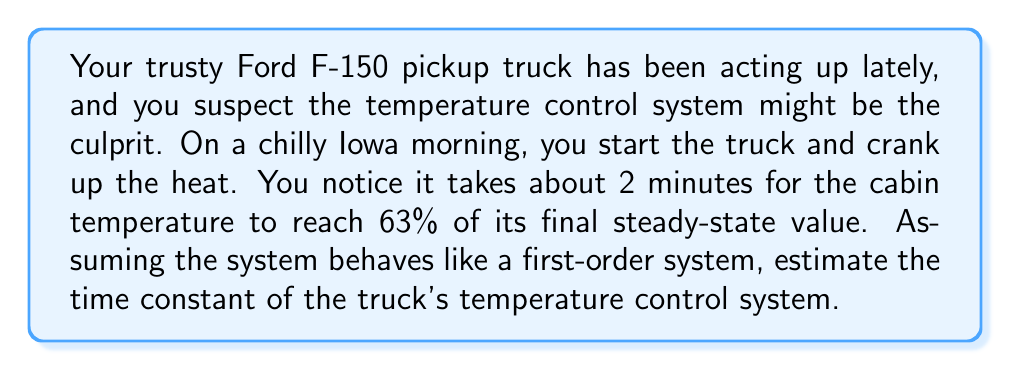Show me your answer to this math problem. To solve this problem, we'll use the properties of a first-order system and the given information. Here's a step-by-step explanation:

1) In a first-order system, the time constant ($\tau$) is defined as the time it takes for the system to reach 63.2% of its final steady-state value.

2) We're told that the cabin temperature reaches 63% of its final value in 2 minutes. This is very close to the definition of the time constant (63.2%).

3) Therefore, we can approximate the time constant as being equal to the time given:

   $\tau \approx 2$ minutes

4) To be more precise, we can use the exponential response equation of a first-order system:

   $\frac{T(t) - T_i}{T_f - T_i} = 1 - e^{-t/\tau}$

   Where:
   $T(t)$ is the temperature at time $t$
   $T_i$ is the initial temperature
   $T_f$ is the final steady-state temperature
   $t$ is the time
   $\tau$ is the time constant

5) We know that at $t = 2$ minutes, the system has reached 63% of its final value. This means:

   $\frac{T(2) - T_i}{T_f - T_i} = 0.63 = 1 - e^{-2/\tau}$

6) Solving for $\tau$:

   $e^{-2/\tau} = 1 - 0.63 = 0.37$
   $-2/\tau = \ln(0.37)$
   $\tau = -2 / \ln(0.37) \approx 2.017$ minutes

Therefore, the time constant of the truck's temperature control system is approximately 2.017 minutes.
Answer: $\tau \approx 2.017$ minutes 